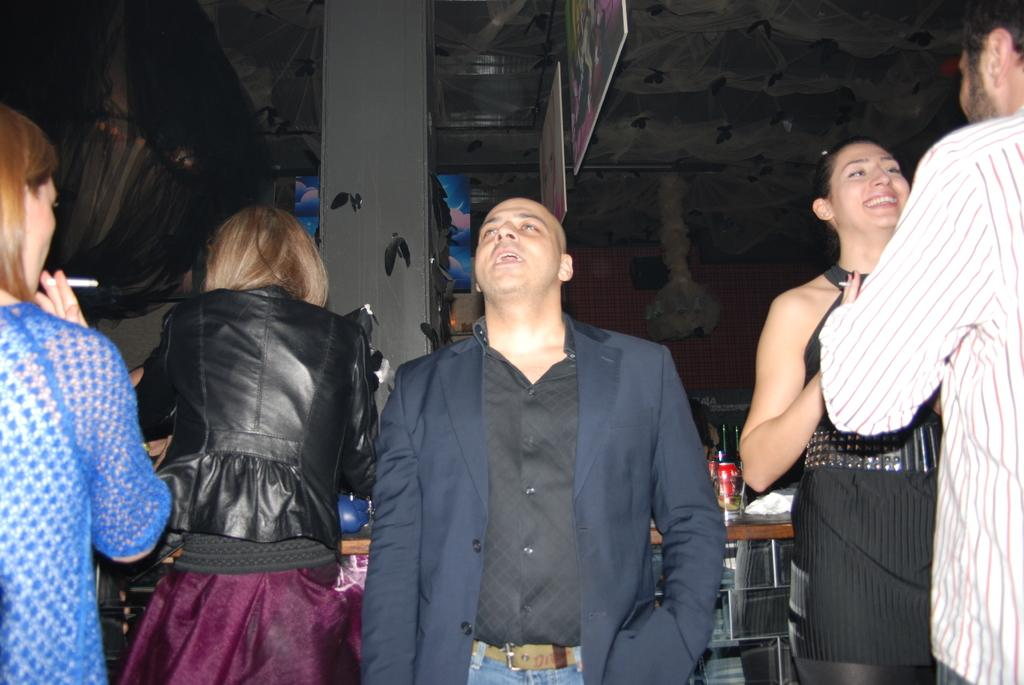What is the main subject in the middle of the image? There is a person in the middle of the image. What objects can be seen in the image? There are glasses visible in the image. Who else is present in the image besides the person in the middle? There are women and men in the image. What type of dog can be seen playing with a sponge in the image? There is no dog or sponge present in the image; it only features a person, glasses, women, and men. 